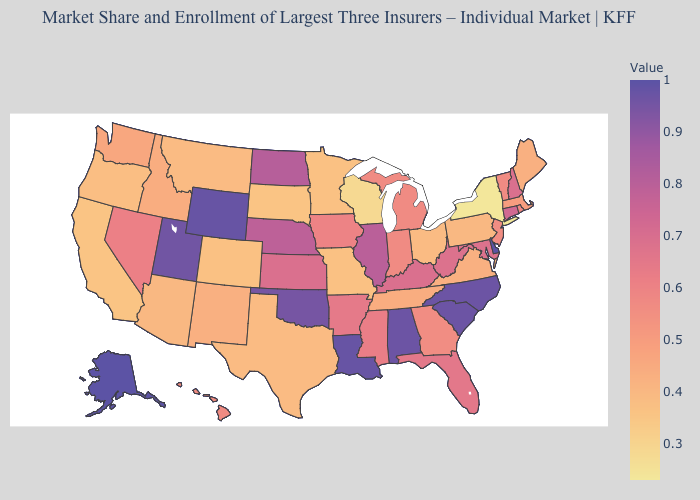Does the map have missing data?
Write a very short answer. No. Among the states that border Tennessee , does Mississippi have the lowest value?
Answer briefly. No. 